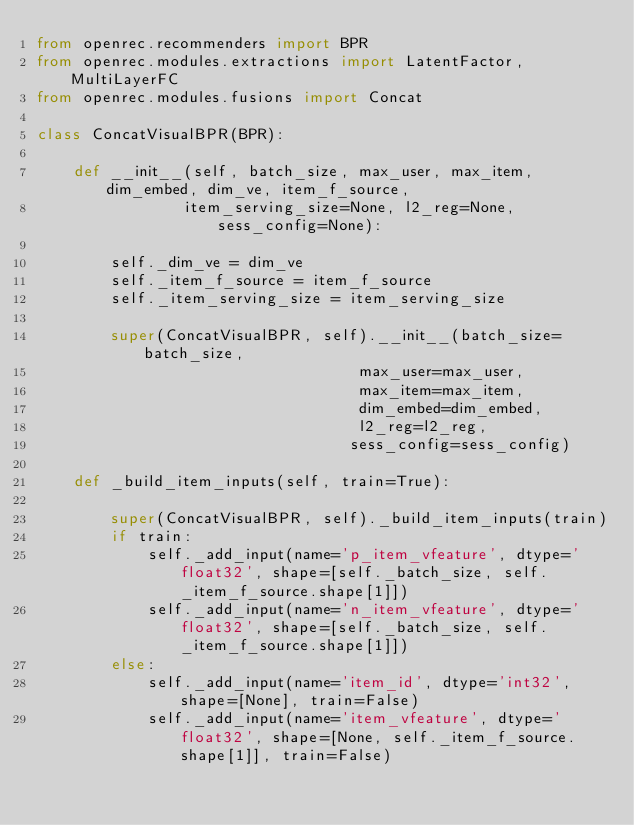<code> <loc_0><loc_0><loc_500><loc_500><_Python_>from openrec.recommenders import BPR
from openrec.modules.extractions import LatentFactor, MultiLayerFC
from openrec.modules.fusions import Concat

class ConcatVisualBPR(BPR):

    def __init__(self, batch_size, max_user, max_item, dim_embed, dim_ve, item_f_source, 
                item_serving_size=None, l2_reg=None, sess_config=None):
        
        self._dim_ve = dim_ve
        self._item_f_source = item_f_source
        self._item_serving_size = item_serving_size
        
        super(ConcatVisualBPR, self).__init__(batch_size=batch_size, 
                                   max_user=max_user, 
                                   max_item=max_item,
                                   dim_embed=dim_embed, 
                                   l2_reg=l2_reg,
                                  sess_config=sess_config)

    def _build_item_inputs(self, train=True):
        
        super(ConcatVisualBPR, self)._build_item_inputs(train)
        if train:
            self._add_input(name='p_item_vfeature', dtype='float32', shape=[self._batch_size, self._item_f_source.shape[1]])
            self._add_input(name='n_item_vfeature', dtype='float32', shape=[self._batch_size, self._item_f_source.shape[1]])
        else:
            self._add_input(name='item_id', dtype='int32', shape=[None], train=False)
            self._add_input(name='item_vfeature', dtype='float32', shape=[None, self._item_f_source.shape[1]], train=False)
</code> 